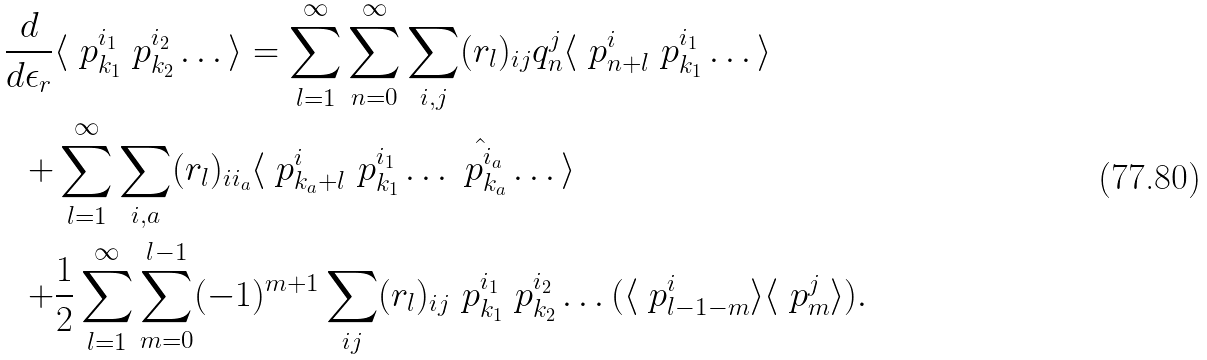<formula> <loc_0><loc_0><loc_500><loc_500>\frac { d } { d \epsilon _ { r } } & \langle \ p ^ { i _ { 1 } } _ { k _ { 1 } } \ p ^ { i _ { 2 } } _ { k _ { 2 } } \dots \rangle = \sum _ { l = 1 } ^ { \infty } \sum _ { n = 0 } ^ { \infty } \sum _ { i , j } ( r _ { l } ) _ { i j } q ^ { j } _ { n } \langle \ p ^ { i } _ { n + l } \ p ^ { i _ { 1 } } _ { k _ { 1 } } \dots \rangle \\ + & \sum _ { l = 1 } ^ { \infty } \sum _ { i , a } ( r _ { l } ) _ { i i _ { a } } \langle \ p ^ { i } _ { k _ { a } + l } \ p ^ { i _ { 1 } } _ { k _ { 1 } } \dots \hat { \ p ^ { i _ { a } } _ { k _ { a } } } \dots \rangle \\ + & \frac { 1 } { 2 } \sum _ { l = 1 } ^ { \infty } \sum _ { m = 0 } ^ { l - 1 } ( - 1 ) ^ { m + 1 } \sum _ { i j } ( r _ { l } ) _ { i j } \ p ^ { i _ { 1 } } _ { k _ { 1 } } \ p ^ { i _ { 2 } } _ { k _ { 2 } } \dots ( \langle \ p ^ { i } _ { l - 1 - m } \rangle \langle \ p ^ { j } _ { m } \rangle ) .</formula> 